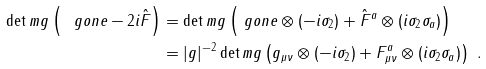Convert formula to latex. <formula><loc_0><loc_0><loc_500><loc_500>\det m g \left ( \ g o n e - 2 i \hat { F } \right ) & = \det m g \left ( \ g o n e \otimes ( - i \sigma _ { 2 } ) + \hat { F } ^ { a } \otimes ( i \sigma _ { 2 } \sigma _ { a } ) \right ) \\ & = | g | ^ { - 2 } \det m g \left ( g _ { \mu \nu } \otimes ( - i \sigma _ { 2 } ) + F ^ { a } _ { \mu \nu } \otimes ( i \sigma _ { 2 } \sigma _ { a } ) \right ) \ .</formula> 